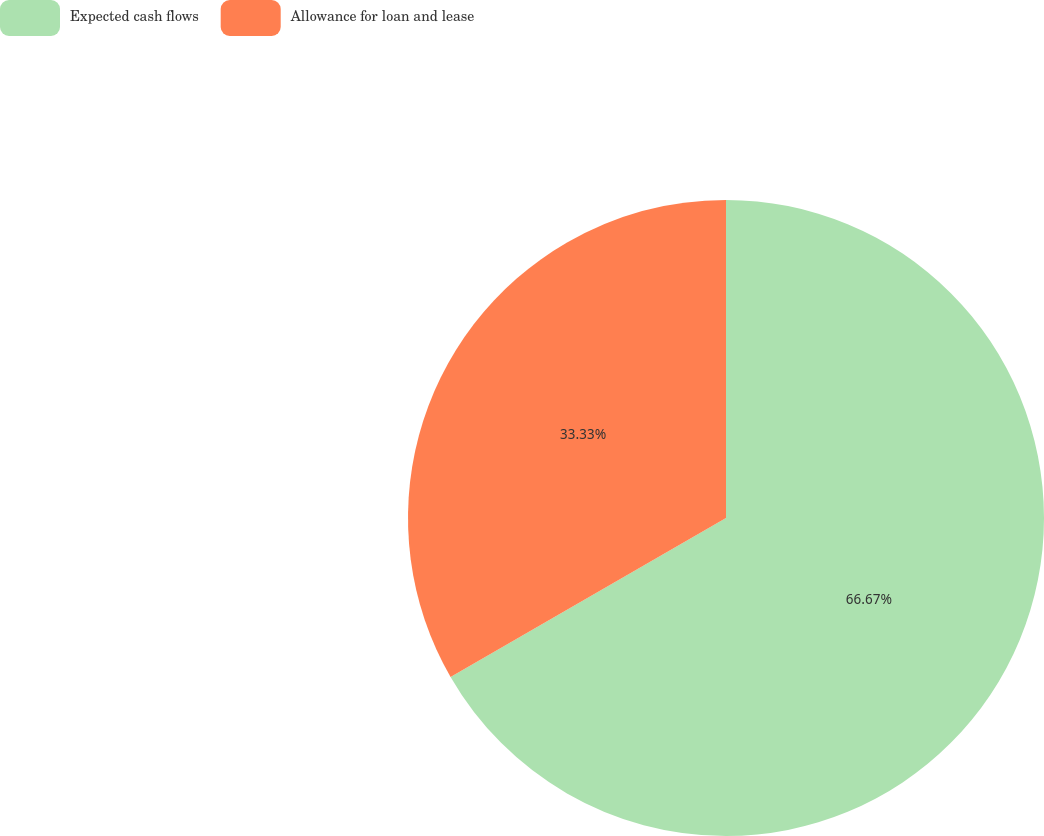<chart> <loc_0><loc_0><loc_500><loc_500><pie_chart><fcel>Expected cash flows<fcel>Allowance for loan and lease<nl><fcel>66.67%<fcel>33.33%<nl></chart> 